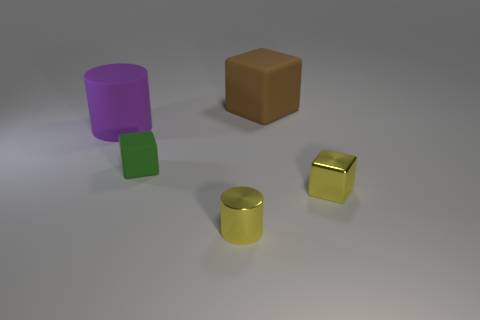The big purple rubber thing has what shape?
Your response must be concise. Cylinder. Is the size of the cylinder behind the shiny cube the same as the small green matte thing?
Your answer should be very brief. No. Is there a small green block made of the same material as the brown block?
Provide a short and direct response. Yes. How many things are tiny yellow objects that are behind the yellow metallic cylinder or small cyan matte balls?
Your answer should be very brief. 1. Is there a tiny matte cylinder?
Give a very brief answer. No. There is a thing that is both in front of the purple cylinder and behind the small yellow metal block; what is its shape?
Keep it short and to the point. Cube. There is a object behind the matte cylinder; what is its size?
Make the answer very short. Large. Is the color of the tiny metal cube in front of the large matte cylinder the same as the small cylinder?
Make the answer very short. Yes. What number of tiny green things are the same shape as the brown matte thing?
Your response must be concise. 1. What number of objects are yellow objects to the right of the brown block or cubes that are behind the rubber cylinder?
Offer a very short reply. 2. 